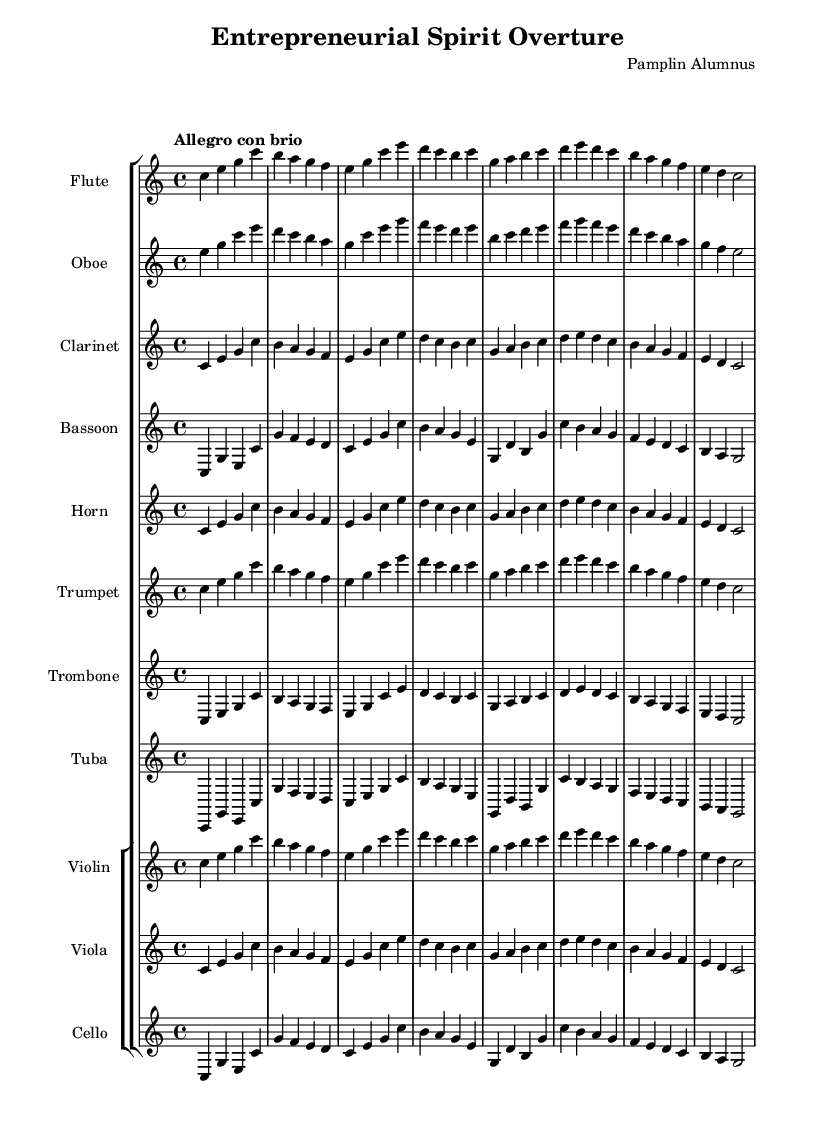What is the tempo marking of this music? The tempo marking indicates "Allegro con brio," meaning a fast and lively pace. This is found in the header section and is a standard way to denote the speed of the piece.
Answer: Allegro con brio What is the time signature of this music? The time signature is indicated as 4/4. This means there are four beats in each measure, and the quarter note gets one beat. This is observed in the global section of the code.
Answer: 4/4 How many different instruments are indicated in the score? The score includes a total of 11 instruments, as listed in the score's section. Each instrument has its own staff, and the total can be counted directly from the provided structure.
Answer: 11 What is the key signature of this music? The key signature is C major, which has no sharps or flats. This is specified in the global section of the sheet music, where the key is directly stated.
Answer: C major Which instrument plays the highest pitch? The flute generally has the highest pitch range among the listed instruments. This can be deduced from the traditional ranges of orchestral instruments, where the flute typically plays higher than the clarinet and oboe.
Answer: Flute Which section of the score do the brass instruments belong to? The brass instruments (horn, trumpet, trombone, and tuba) belong to the first staff group labeled as "Brass". They are grouped together in the score, making it easy to identify their section.
Answer: Brass What thematic inspiration does this symphonic suite celebrate? The suite celebrates business innovation and leadership. This thematic inspiration can be inferred from the title "Entrepreneurial Spirit Overture," which suggests a focus on entrepreneurial values.
Answer: Business innovation and leadership 